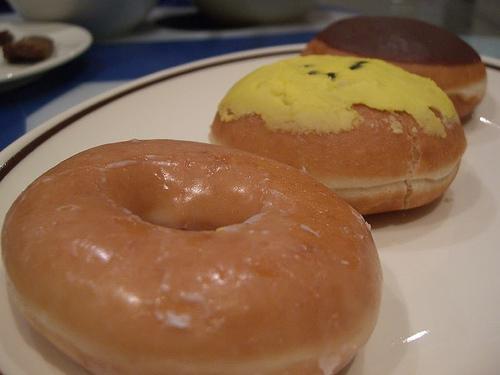How many doughnuts are there?
Concise answer only. 3. How many varieties of donuts is there?
Concise answer only. 3. How many different types of doughnuts are there?
Write a very short answer. 3. How many calories are in just one of these doughnuts?
Quick response, please. 500. 